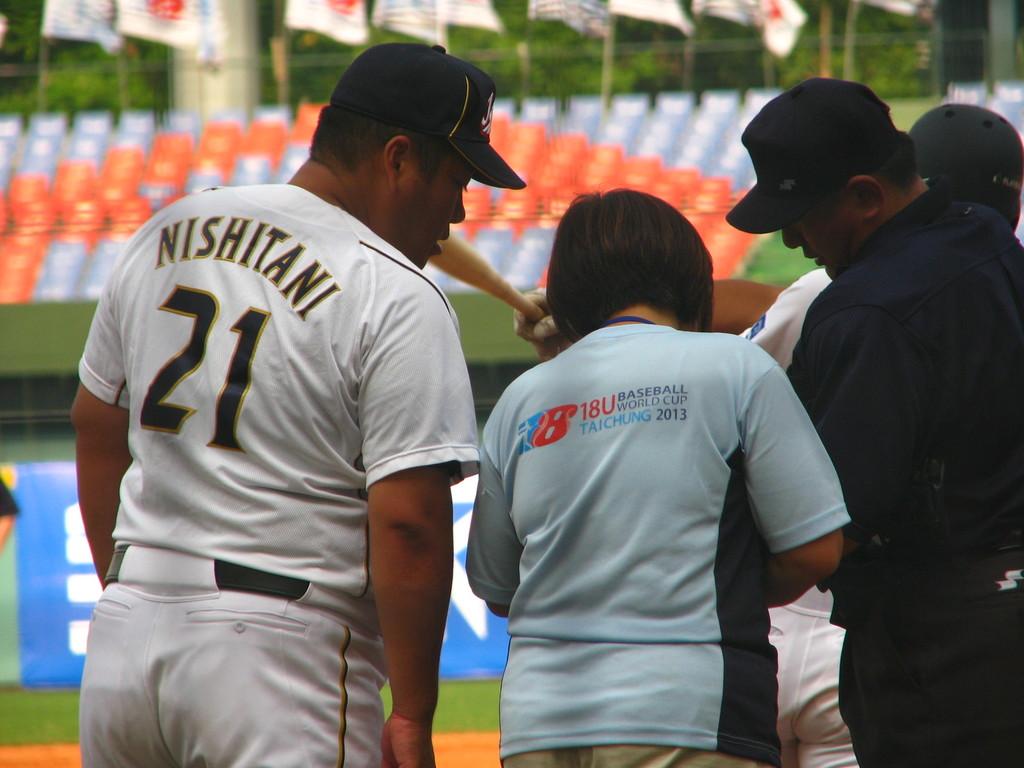What is written on the middle persons shirt back?
Your answer should be very brief. 18u baseball world cup taichung 2013. 